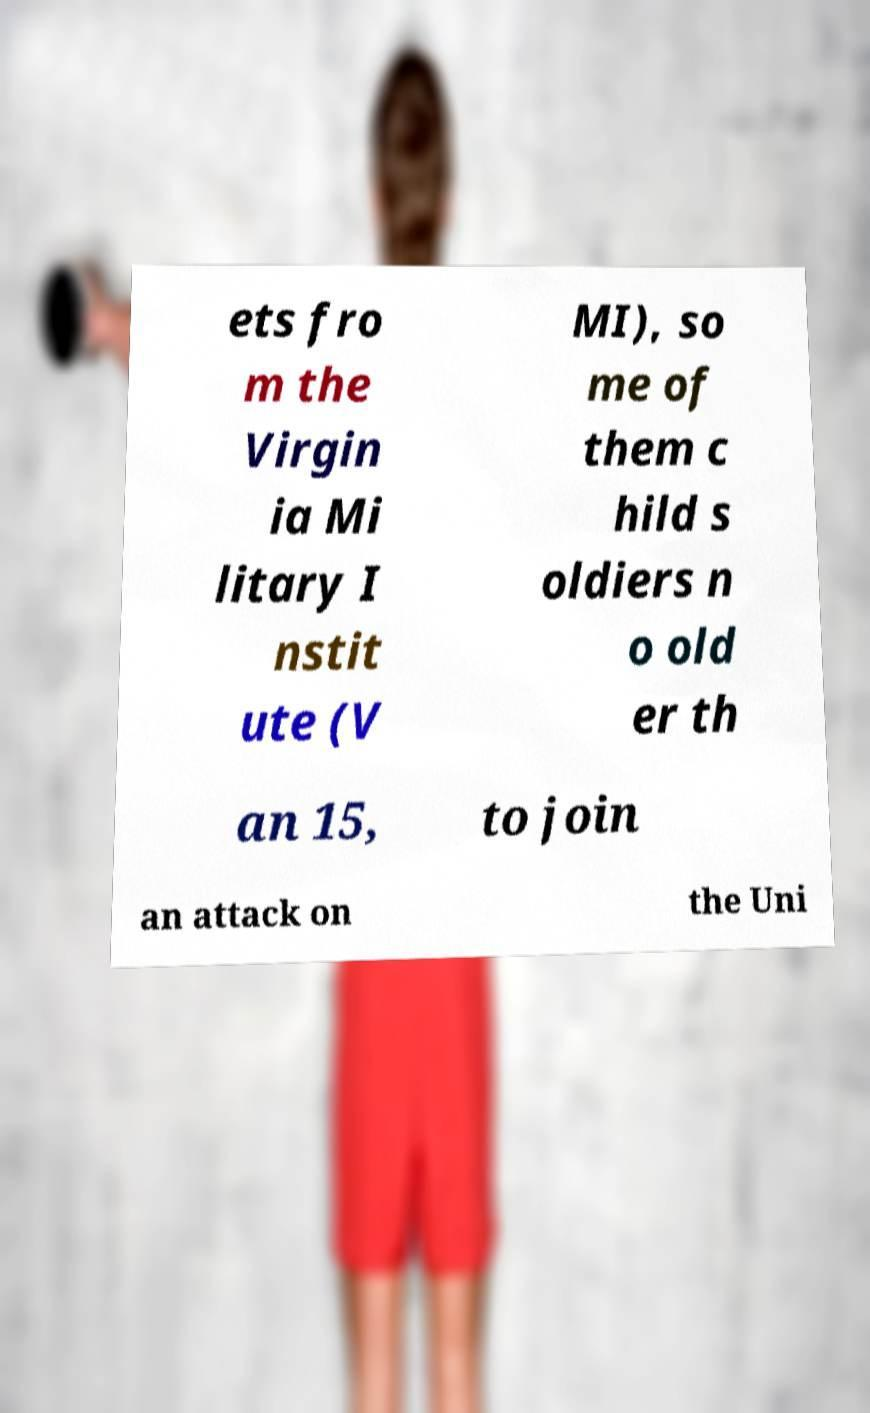Please identify and transcribe the text found in this image. ets fro m the Virgin ia Mi litary I nstit ute (V MI), so me of them c hild s oldiers n o old er th an 15, to join an attack on the Uni 